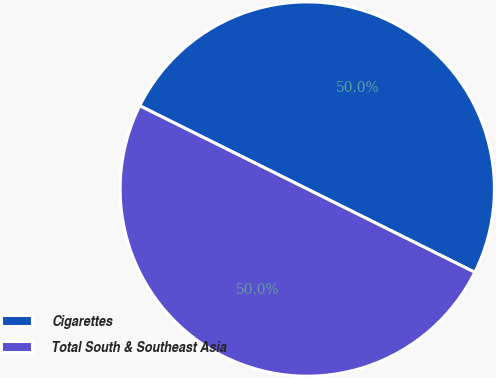<chart> <loc_0><loc_0><loc_500><loc_500><pie_chart><fcel>Cigarettes<fcel>Total South & Southeast Asia<nl><fcel>50.0%<fcel>50.0%<nl></chart> 